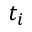<formula> <loc_0><loc_0><loc_500><loc_500>t _ { i }</formula> 